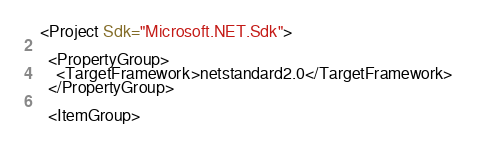<code> <loc_0><loc_0><loc_500><loc_500><_XML_><Project Sdk="Microsoft.NET.Sdk">

  <PropertyGroup>
    <TargetFramework>netstandard2.0</TargetFramework>
  </PropertyGroup>

  <ItemGroup></code> 